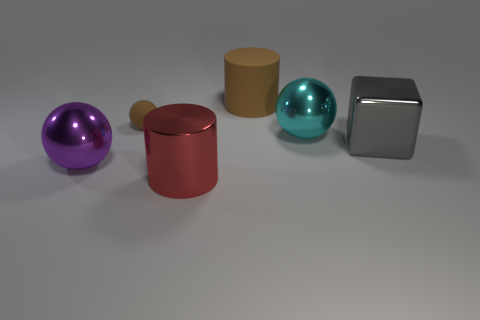Subtract all metal spheres. How many spheres are left? 1 Add 2 big yellow metallic blocks. How many objects exist? 8 Subtract all cylinders. How many objects are left? 4 Subtract all green spheres. Subtract all blue cylinders. How many spheres are left? 3 Subtract all shiny objects. Subtract all tiny blue rubber cylinders. How many objects are left? 2 Add 6 big brown things. How many big brown things are left? 7 Add 4 cyan shiny objects. How many cyan shiny objects exist? 5 Subtract 0 red cubes. How many objects are left? 6 